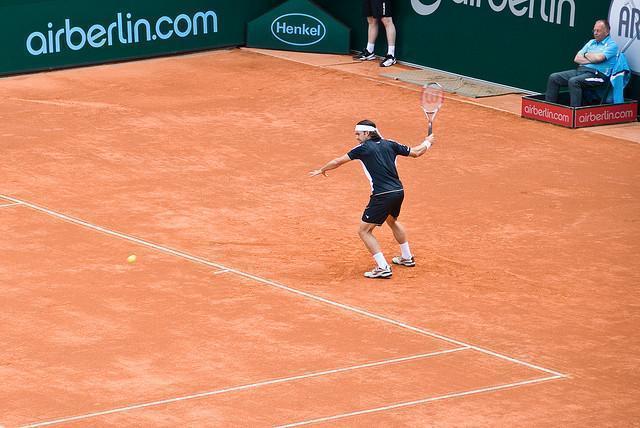In which country is the city mentioned here located?
Choose the correct response and explain in the format: 'Answer: answer
Rationale: rationale.'
Options: Austria, france, germany, us. Answer: germany.
Rationale: Berlin is in germany. 